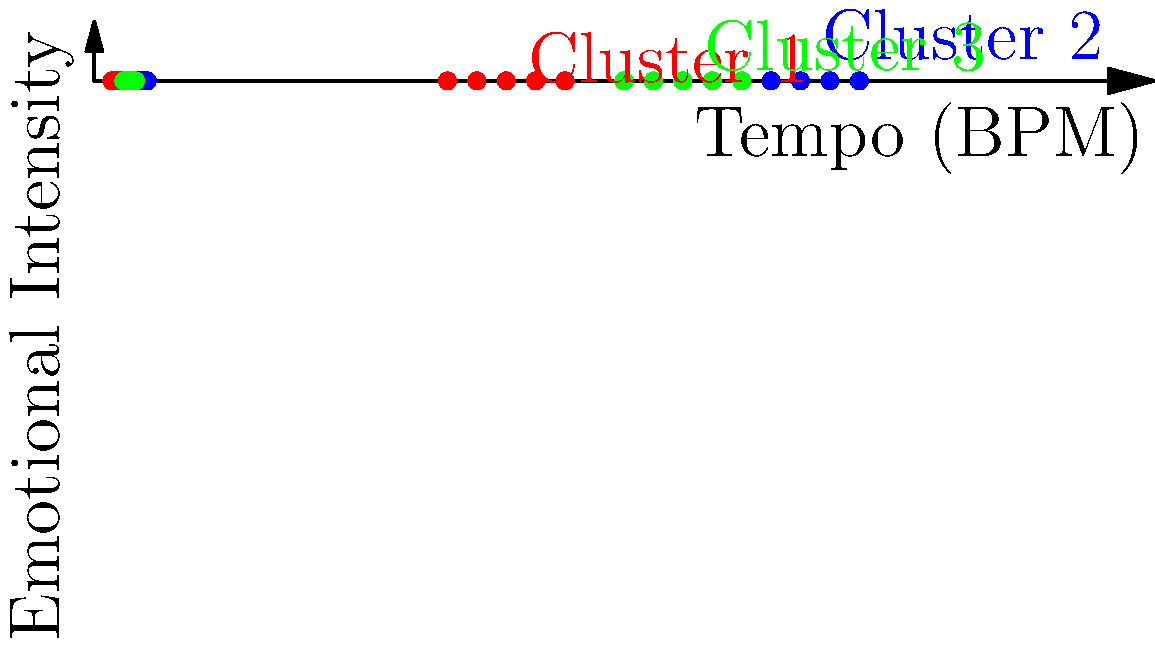Based on the scatter plot showing the clustering of patients' musical preferences, which cluster represents songs that are likely to be most effective for relaxation therapy sessions? To determine which cluster is most suitable for relaxation therapy, we need to analyze the characteristics of each cluster:

1. Understand the axes:
   - X-axis represents Tempo (BPM - Beats Per Minute)
   - Y-axis represents Emotional Intensity

2. Analyze each cluster:
   - Cluster 1 (Red): Low tempo (60-80 BPM) and low emotional intensity (3-5)
   - Cluster 2 (Blue): High tempo (110-130 BPM) and high emotional intensity (7-9)
   - Cluster 3 (Green): Medium tempo (90-110 BPM) and medium emotional intensity (5-7)

3. Consider the properties of music suitable for relaxation:
   - Lower tempos are generally more calming
   - Lower emotional intensity is usually less stimulating

4. Compare the clusters:
   - Cluster 1 has the lowest tempo and emotional intensity
   - Cluster 2 has the highest tempo and emotional intensity
   - Cluster 3 falls in between

5. Conclusion:
   Cluster 1 (Red) represents songs with the lowest tempo and emotional intensity, making them the most suitable for relaxation therapy sessions.
Answer: Cluster 1 (Red) 